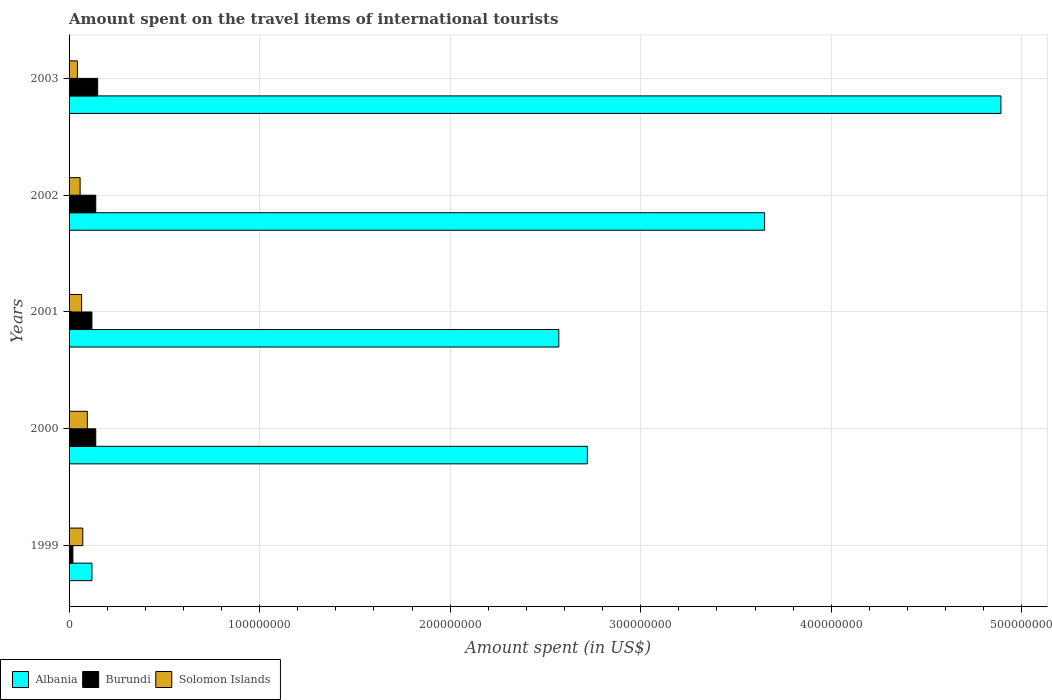How many groups of bars are there?
Make the answer very short. 5. Are the number of bars per tick equal to the number of legend labels?
Give a very brief answer. Yes. Are the number of bars on each tick of the Y-axis equal?
Your answer should be compact. Yes. In how many cases, is the number of bars for a given year not equal to the number of legend labels?
Provide a short and direct response. 0. What is the amount spent on the travel items of international tourists in Burundi in 2002?
Your response must be concise. 1.40e+07. Across all years, what is the maximum amount spent on the travel items of international tourists in Burundi?
Keep it short and to the point. 1.50e+07. Across all years, what is the minimum amount spent on the travel items of international tourists in Solomon Islands?
Your answer should be compact. 4.40e+06. In which year was the amount spent on the travel items of international tourists in Burundi maximum?
Make the answer very short. 2003. In which year was the amount spent on the travel items of international tourists in Solomon Islands minimum?
Keep it short and to the point. 2003. What is the total amount spent on the travel items of international tourists in Burundi in the graph?
Your answer should be compact. 5.70e+07. What is the difference between the amount spent on the travel items of international tourists in Burundi in 2001 and that in 2003?
Your response must be concise. -3.00e+06. What is the difference between the amount spent on the travel items of international tourists in Burundi in 2001 and the amount spent on the travel items of international tourists in Solomon Islands in 2003?
Your answer should be compact. 7.60e+06. What is the average amount spent on the travel items of international tourists in Albania per year?
Ensure brevity in your answer.  2.79e+08. In the year 1999, what is the difference between the amount spent on the travel items of international tourists in Solomon Islands and amount spent on the travel items of international tourists in Albania?
Ensure brevity in your answer.  -4.80e+06. What is the ratio of the amount spent on the travel items of international tourists in Solomon Islands in 1999 to that in 2002?
Keep it short and to the point. 1.24. What is the difference between the highest and the second highest amount spent on the travel items of international tourists in Albania?
Provide a short and direct response. 1.24e+08. What is the difference between the highest and the lowest amount spent on the travel items of international tourists in Burundi?
Ensure brevity in your answer.  1.30e+07. In how many years, is the amount spent on the travel items of international tourists in Solomon Islands greater than the average amount spent on the travel items of international tourists in Solomon Islands taken over all years?
Your answer should be compact. 2. Is the sum of the amount spent on the travel items of international tourists in Albania in 2000 and 2003 greater than the maximum amount spent on the travel items of international tourists in Solomon Islands across all years?
Ensure brevity in your answer.  Yes. What does the 1st bar from the top in 2001 represents?
Your answer should be very brief. Solomon Islands. What does the 2nd bar from the bottom in 2001 represents?
Keep it short and to the point. Burundi. How many bars are there?
Offer a very short reply. 15. How many years are there in the graph?
Keep it short and to the point. 5. Does the graph contain grids?
Make the answer very short. Yes. How are the legend labels stacked?
Make the answer very short. Horizontal. What is the title of the graph?
Keep it short and to the point. Amount spent on the travel items of international tourists. What is the label or title of the X-axis?
Provide a short and direct response. Amount spent (in US$). What is the label or title of the Y-axis?
Keep it short and to the point. Years. What is the Amount spent (in US$) in Burundi in 1999?
Ensure brevity in your answer.  2.00e+06. What is the Amount spent (in US$) in Solomon Islands in 1999?
Ensure brevity in your answer.  7.20e+06. What is the Amount spent (in US$) in Albania in 2000?
Provide a short and direct response. 2.72e+08. What is the Amount spent (in US$) of Burundi in 2000?
Your response must be concise. 1.40e+07. What is the Amount spent (in US$) in Solomon Islands in 2000?
Your answer should be compact. 9.60e+06. What is the Amount spent (in US$) in Albania in 2001?
Give a very brief answer. 2.57e+08. What is the Amount spent (in US$) of Solomon Islands in 2001?
Provide a succinct answer. 6.60e+06. What is the Amount spent (in US$) of Albania in 2002?
Your response must be concise. 3.65e+08. What is the Amount spent (in US$) of Burundi in 2002?
Offer a very short reply. 1.40e+07. What is the Amount spent (in US$) in Solomon Islands in 2002?
Your response must be concise. 5.80e+06. What is the Amount spent (in US$) of Albania in 2003?
Offer a terse response. 4.89e+08. What is the Amount spent (in US$) of Burundi in 2003?
Offer a terse response. 1.50e+07. What is the Amount spent (in US$) of Solomon Islands in 2003?
Offer a terse response. 4.40e+06. Across all years, what is the maximum Amount spent (in US$) in Albania?
Provide a succinct answer. 4.89e+08. Across all years, what is the maximum Amount spent (in US$) of Burundi?
Provide a succinct answer. 1.50e+07. Across all years, what is the maximum Amount spent (in US$) of Solomon Islands?
Ensure brevity in your answer.  9.60e+06. Across all years, what is the minimum Amount spent (in US$) in Albania?
Your answer should be very brief. 1.20e+07. Across all years, what is the minimum Amount spent (in US$) in Solomon Islands?
Offer a very short reply. 4.40e+06. What is the total Amount spent (in US$) of Albania in the graph?
Offer a terse response. 1.40e+09. What is the total Amount spent (in US$) in Burundi in the graph?
Your answer should be compact. 5.70e+07. What is the total Amount spent (in US$) in Solomon Islands in the graph?
Your answer should be very brief. 3.36e+07. What is the difference between the Amount spent (in US$) of Albania in 1999 and that in 2000?
Give a very brief answer. -2.60e+08. What is the difference between the Amount spent (in US$) in Burundi in 1999 and that in 2000?
Keep it short and to the point. -1.20e+07. What is the difference between the Amount spent (in US$) of Solomon Islands in 1999 and that in 2000?
Offer a terse response. -2.40e+06. What is the difference between the Amount spent (in US$) of Albania in 1999 and that in 2001?
Make the answer very short. -2.45e+08. What is the difference between the Amount spent (in US$) of Burundi in 1999 and that in 2001?
Ensure brevity in your answer.  -1.00e+07. What is the difference between the Amount spent (in US$) of Solomon Islands in 1999 and that in 2001?
Make the answer very short. 6.00e+05. What is the difference between the Amount spent (in US$) of Albania in 1999 and that in 2002?
Your answer should be very brief. -3.53e+08. What is the difference between the Amount spent (in US$) of Burundi in 1999 and that in 2002?
Provide a short and direct response. -1.20e+07. What is the difference between the Amount spent (in US$) of Solomon Islands in 1999 and that in 2002?
Provide a succinct answer. 1.40e+06. What is the difference between the Amount spent (in US$) in Albania in 1999 and that in 2003?
Offer a very short reply. -4.77e+08. What is the difference between the Amount spent (in US$) of Burundi in 1999 and that in 2003?
Your response must be concise. -1.30e+07. What is the difference between the Amount spent (in US$) of Solomon Islands in 1999 and that in 2003?
Your response must be concise. 2.80e+06. What is the difference between the Amount spent (in US$) of Albania in 2000 and that in 2001?
Your answer should be compact. 1.50e+07. What is the difference between the Amount spent (in US$) of Albania in 2000 and that in 2002?
Your answer should be compact. -9.30e+07. What is the difference between the Amount spent (in US$) of Solomon Islands in 2000 and that in 2002?
Offer a very short reply. 3.80e+06. What is the difference between the Amount spent (in US$) of Albania in 2000 and that in 2003?
Provide a succinct answer. -2.17e+08. What is the difference between the Amount spent (in US$) in Solomon Islands in 2000 and that in 2003?
Provide a succinct answer. 5.20e+06. What is the difference between the Amount spent (in US$) of Albania in 2001 and that in 2002?
Offer a terse response. -1.08e+08. What is the difference between the Amount spent (in US$) in Albania in 2001 and that in 2003?
Your answer should be very brief. -2.32e+08. What is the difference between the Amount spent (in US$) of Burundi in 2001 and that in 2003?
Make the answer very short. -3.00e+06. What is the difference between the Amount spent (in US$) of Solomon Islands in 2001 and that in 2003?
Your answer should be very brief. 2.20e+06. What is the difference between the Amount spent (in US$) of Albania in 2002 and that in 2003?
Provide a succinct answer. -1.24e+08. What is the difference between the Amount spent (in US$) in Burundi in 2002 and that in 2003?
Your response must be concise. -1.00e+06. What is the difference between the Amount spent (in US$) of Solomon Islands in 2002 and that in 2003?
Provide a succinct answer. 1.40e+06. What is the difference between the Amount spent (in US$) of Albania in 1999 and the Amount spent (in US$) of Solomon Islands in 2000?
Provide a short and direct response. 2.40e+06. What is the difference between the Amount spent (in US$) of Burundi in 1999 and the Amount spent (in US$) of Solomon Islands in 2000?
Provide a succinct answer. -7.60e+06. What is the difference between the Amount spent (in US$) of Albania in 1999 and the Amount spent (in US$) of Burundi in 2001?
Provide a succinct answer. 0. What is the difference between the Amount spent (in US$) of Albania in 1999 and the Amount spent (in US$) of Solomon Islands in 2001?
Your response must be concise. 5.40e+06. What is the difference between the Amount spent (in US$) of Burundi in 1999 and the Amount spent (in US$) of Solomon Islands in 2001?
Your response must be concise. -4.60e+06. What is the difference between the Amount spent (in US$) in Albania in 1999 and the Amount spent (in US$) in Solomon Islands in 2002?
Your answer should be compact. 6.20e+06. What is the difference between the Amount spent (in US$) of Burundi in 1999 and the Amount spent (in US$) of Solomon Islands in 2002?
Give a very brief answer. -3.80e+06. What is the difference between the Amount spent (in US$) in Albania in 1999 and the Amount spent (in US$) in Burundi in 2003?
Keep it short and to the point. -3.00e+06. What is the difference between the Amount spent (in US$) of Albania in 1999 and the Amount spent (in US$) of Solomon Islands in 2003?
Keep it short and to the point. 7.60e+06. What is the difference between the Amount spent (in US$) in Burundi in 1999 and the Amount spent (in US$) in Solomon Islands in 2003?
Give a very brief answer. -2.40e+06. What is the difference between the Amount spent (in US$) in Albania in 2000 and the Amount spent (in US$) in Burundi in 2001?
Keep it short and to the point. 2.60e+08. What is the difference between the Amount spent (in US$) in Albania in 2000 and the Amount spent (in US$) in Solomon Islands in 2001?
Keep it short and to the point. 2.65e+08. What is the difference between the Amount spent (in US$) of Burundi in 2000 and the Amount spent (in US$) of Solomon Islands in 2001?
Ensure brevity in your answer.  7.40e+06. What is the difference between the Amount spent (in US$) of Albania in 2000 and the Amount spent (in US$) of Burundi in 2002?
Offer a terse response. 2.58e+08. What is the difference between the Amount spent (in US$) in Albania in 2000 and the Amount spent (in US$) in Solomon Islands in 2002?
Provide a short and direct response. 2.66e+08. What is the difference between the Amount spent (in US$) in Burundi in 2000 and the Amount spent (in US$) in Solomon Islands in 2002?
Keep it short and to the point. 8.20e+06. What is the difference between the Amount spent (in US$) of Albania in 2000 and the Amount spent (in US$) of Burundi in 2003?
Give a very brief answer. 2.57e+08. What is the difference between the Amount spent (in US$) of Albania in 2000 and the Amount spent (in US$) of Solomon Islands in 2003?
Your answer should be compact. 2.68e+08. What is the difference between the Amount spent (in US$) of Burundi in 2000 and the Amount spent (in US$) of Solomon Islands in 2003?
Your response must be concise. 9.60e+06. What is the difference between the Amount spent (in US$) in Albania in 2001 and the Amount spent (in US$) in Burundi in 2002?
Offer a terse response. 2.43e+08. What is the difference between the Amount spent (in US$) of Albania in 2001 and the Amount spent (in US$) of Solomon Islands in 2002?
Make the answer very short. 2.51e+08. What is the difference between the Amount spent (in US$) in Burundi in 2001 and the Amount spent (in US$) in Solomon Islands in 2002?
Ensure brevity in your answer.  6.20e+06. What is the difference between the Amount spent (in US$) of Albania in 2001 and the Amount spent (in US$) of Burundi in 2003?
Keep it short and to the point. 2.42e+08. What is the difference between the Amount spent (in US$) of Albania in 2001 and the Amount spent (in US$) of Solomon Islands in 2003?
Offer a very short reply. 2.53e+08. What is the difference between the Amount spent (in US$) in Burundi in 2001 and the Amount spent (in US$) in Solomon Islands in 2003?
Provide a succinct answer. 7.60e+06. What is the difference between the Amount spent (in US$) of Albania in 2002 and the Amount spent (in US$) of Burundi in 2003?
Provide a short and direct response. 3.50e+08. What is the difference between the Amount spent (in US$) of Albania in 2002 and the Amount spent (in US$) of Solomon Islands in 2003?
Offer a very short reply. 3.61e+08. What is the difference between the Amount spent (in US$) of Burundi in 2002 and the Amount spent (in US$) of Solomon Islands in 2003?
Offer a terse response. 9.60e+06. What is the average Amount spent (in US$) of Albania per year?
Ensure brevity in your answer.  2.79e+08. What is the average Amount spent (in US$) in Burundi per year?
Your answer should be very brief. 1.14e+07. What is the average Amount spent (in US$) of Solomon Islands per year?
Offer a very short reply. 6.72e+06. In the year 1999, what is the difference between the Amount spent (in US$) of Albania and Amount spent (in US$) of Burundi?
Provide a short and direct response. 1.00e+07. In the year 1999, what is the difference between the Amount spent (in US$) of Albania and Amount spent (in US$) of Solomon Islands?
Offer a terse response. 4.80e+06. In the year 1999, what is the difference between the Amount spent (in US$) in Burundi and Amount spent (in US$) in Solomon Islands?
Make the answer very short. -5.20e+06. In the year 2000, what is the difference between the Amount spent (in US$) in Albania and Amount spent (in US$) in Burundi?
Provide a succinct answer. 2.58e+08. In the year 2000, what is the difference between the Amount spent (in US$) of Albania and Amount spent (in US$) of Solomon Islands?
Keep it short and to the point. 2.62e+08. In the year 2000, what is the difference between the Amount spent (in US$) in Burundi and Amount spent (in US$) in Solomon Islands?
Offer a terse response. 4.40e+06. In the year 2001, what is the difference between the Amount spent (in US$) of Albania and Amount spent (in US$) of Burundi?
Offer a very short reply. 2.45e+08. In the year 2001, what is the difference between the Amount spent (in US$) of Albania and Amount spent (in US$) of Solomon Islands?
Provide a short and direct response. 2.50e+08. In the year 2001, what is the difference between the Amount spent (in US$) of Burundi and Amount spent (in US$) of Solomon Islands?
Ensure brevity in your answer.  5.40e+06. In the year 2002, what is the difference between the Amount spent (in US$) of Albania and Amount spent (in US$) of Burundi?
Make the answer very short. 3.51e+08. In the year 2002, what is the difference between the Amount spent (in US$) in Albania and Amount spent (in US$) in Solomon Islands?
Offer a very short reply. 3.59e+08. In the year 2002, what is the difference between the Amount spent (in US$) of Burundi and Amount spent (in US$) of Solomon Islands?
Offer a very short reply. 8.20e+06. In the year 2003, what is the difference between the Amount spent (in US$) in Albania and Amount spent (in US$) in Burundi?
Your answer should be compact. 4.74e+08. In the year 2003, what is the difference between the Amount spent (in US$) of Albania and Amount spent (in US$) of Solomon Islands?
Your answer should be very brief. 4.85e+08. In the year 2003, what is the difference between the Amount spent (in US$) in Burundi and Amount spent (in US$) in Solomon Islands?
Keep it short and to the point. 1.06e+07. What is the ratio of the Amount spent (in US$) in Albania in 1999 to that in 2000?
Your answer should be very brief. 0.04. What is the ratio of the Amount spent (in US$) of Burundi in 1999 to that in 2000?
Your answer should be compact. 0.14. What is the ratio of the Amount spent (in US$) in Albania in 1999 to that in 2001?
Provide a short and direct response. 0.05. What is the ratio of the Amount spent (in US$) of Solomon Islands in 1999 to that in 2001?
Offer a very short reply. 1.09. What is the ratio of the Amount spent (in US$) in Albania in 1999 to that in 2002?
Give a very brief answer. 0.03. What is the ratio of the Amount spent (in US$) in Burundi in 1999 to that in 2002?
Make the answer very short. 0.14. What is the ratio of the Amount spent (in US$) of Solomon Islands in 1999 to that in 2002?
Your answer should be compact. 1.24. What is the ratio of the Amount spent (in US$) of Albania in 1999 to that in 2003?
Make the answer very short. 0.02. What is the ratio of the Amount spent (in US$) in Burundi in 1999 to that in 2003?
Your answer should be compact. 0.13. What is the ratio of the Amount spent (in US$) of Solomon Islands in 1999 to that in 2003?
Your answer should be very brief. 1.64. What is the ratio of the Amount spent (in US$) in Albania in 2000 to that in 2001?
Your answer should be compact. 1.06. What is the ratio of the Amount spent (in US$) in Solomon Islands in 2000 to that in 2001?
Provide a succinct answer. 1.45. What is the ratio of the Amount spent (in US$) of Albania in 2000 to that in 2002?
Your answer should be very brief. 0.75. What is the ratio of the Amount spent (in US$) of Solomon Islands in 2000 to that in 2002?
Offer a terse response. 1.66. What is the ratio of the Amount spent (in US$) of Albania in 2000 to that in 2003?
Give a very brief answer. 0.56. What is the ratio of the Amount spent (in US$) of Solomon Islands in 2000 to that in 2003?
Keep it short and to the point. 2.18. What is the ratio of the Amount spent (in US$) of Albania in 2001 to that in 2002?
Your answer should be compact. 0.7. What is the ratio of the Amount spent (in US$) in Burundi in 2001 to that in 2002?
Make the answer very short. 0.86. What is the ratio of the Amount spent (in US$) in Solomon Islands in 2001 to that in 2002?
Keep it short and to the point. 1.14. What is the ratio of the Amount spent (in US$) in Albania in 2001 to that in 2003?
Keep it short and to the point. 0.53. What is the ratio of the Amount spent (in US$) in Burundi in 2001 to that in 2003?
Your response must be concise. 0.8. What is the ratio of the Amount spent (in US$) of Albania in 2002 to that in 2003?
Your answer should be very brief. 0.75. What is the ratio of the Amount spent (in US$) of Burundi in 2002 to that in 2003?
Your answer should be compact. 0.93. What is the ratio of the Amount spent (in US$) in Solomon Islands in 2002 to that in 2003?
Offer a very short reply. 1.32. What is the difference between the highest and the second highest Amount spent (in US$) in Albania?
Provide a short and direct response. 1.24e+08. What is the difference between the highest and the second highest Amount spent (in US$) of Solomon Islands?
Keep it short and to the point. 2.40e+06. What is the difference between the highest and the lowest Amount spent (in US$) of Albania?
Your answer should be very brief. 4.77e+08. What is the difference between the highest and the lowest Amount spent (in US$) in Burundi?
Keep it short and to the point. 1.30e+07. What is the difference between the highest and the lowest Amount spent (in US$) of Solomon Islands?
Provide a short and direct response. 5.20e+06. 